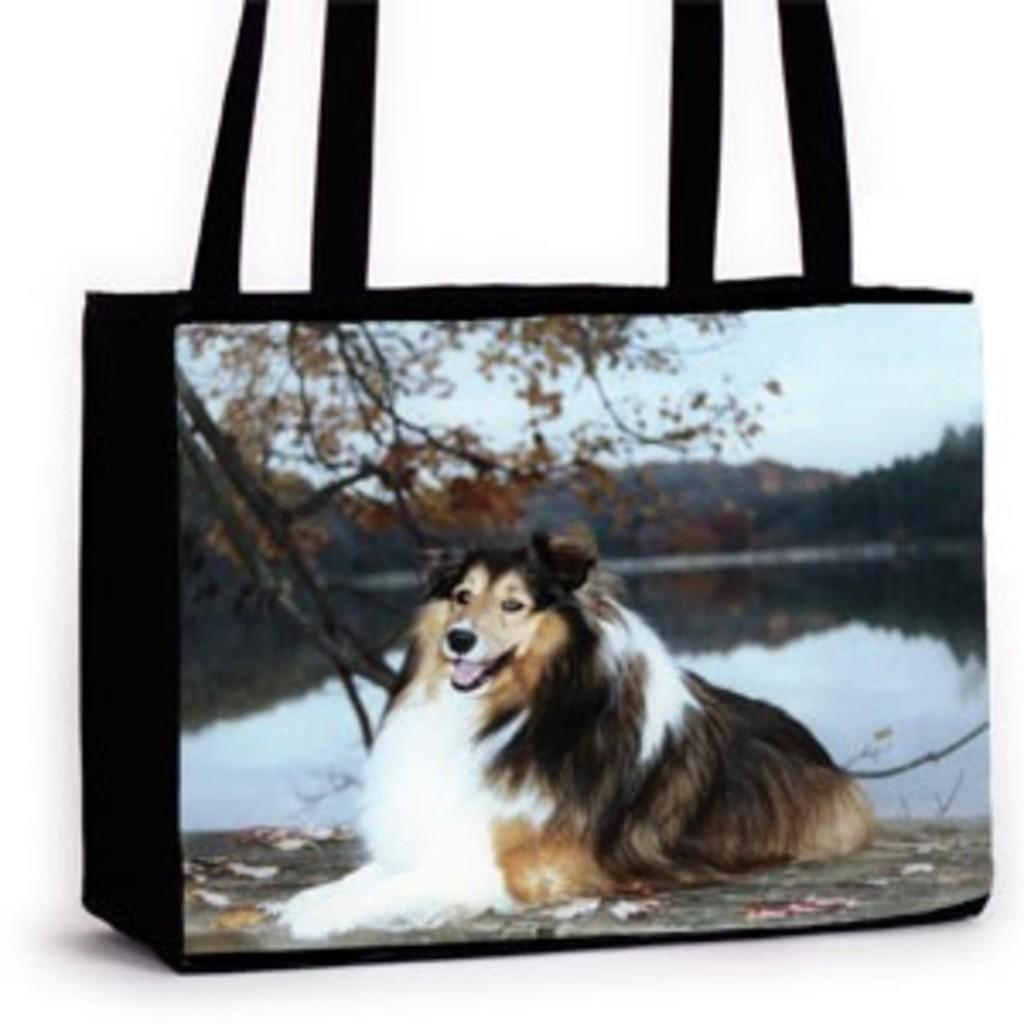What object with straps can be seen in the image? There is a bag with straps in the image. What animal is sitting on the floor next to the bag? A dog is sitting on the floor next to the bag. What natural element is visible in the image? Water is visible in the image. What type of vegetation can be seen in the image? There are trees in the image. What geographical feature is present in the image? There are mountains in the image. What part of the natural environment is visible in the image? The sky is visible in the image. What type of fear can be seen on the dog's face in the image? There is no indication of fear on the dog's face in the image. What scientific experiment is being conducted in the image? There is no scientific experiment present in the image. 